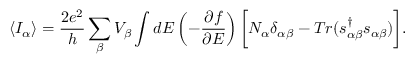Convert formula to latex. <formula><loc_0><loc_0><loc_500><loc_500>\langle I _ { \alpha } \rangle = \frac { 2 e ^ { 2 } } { h } \sum _ { \beta } V _ { \beta } \int d E \left ( - \frac { \partial f } { \partial E } \right ) \left [ N _ { \alpha } \delta _ { \alpha \beta } - T r ( s _ { \alpha \beta } ^ { \dagger } s _ { \alpha \beta } ) \right ] .</formula> 